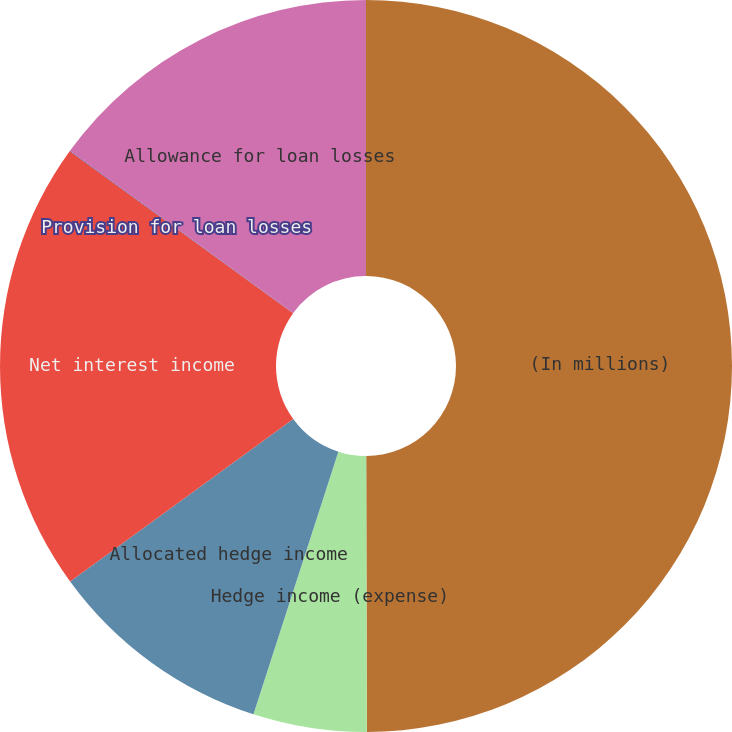Convert chart to OTSL. <chart><loc_0><loc_0><loc_500><loc_500><pie_chart><fcel>(In millions)<fcel>Hedge income (expense)<fcel>Allocated hedge income<fcel>Net interest income<fcel>Provision for loan losses<fcel>Allowance for loan losses<nl><fcel>49.97%<fcel>5.01%<fcel>10.01%<fcel>20.0%<fcel>0.02%<fcel>15.0%<nl></chart> 